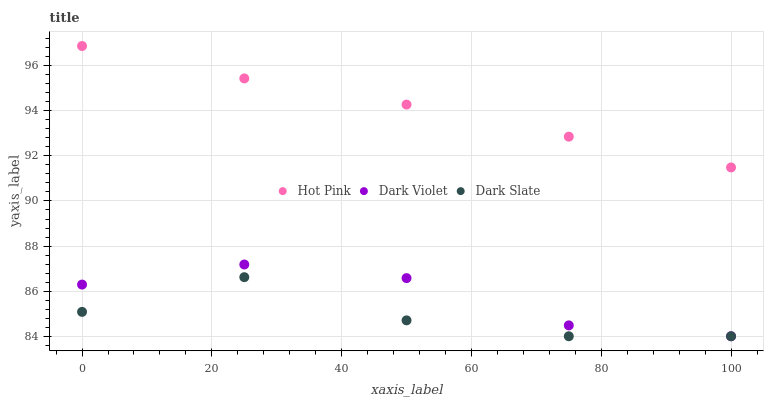Does Dark Slate have the minimum area under the curve?
Answer yes or no. Yes. Does Hot Pink have the maximum area under the curve?
Answer yes or no. Yes. Does Dark Violet have the minimum area under the curve?
Answer yes or no. No. Does Dark Violet have the maximum area under the curve?
Answer yes or no. No. Is Hot Pink the smoothest?
Answer yes or no. Yes. Is Dark Slate the roughest?
Answer yes or no. Yes. Is Dark Violet the smoothest?
Answer yes or no. No. Is Dark Violet the roughest?
Answer yes or no. No. Does Dark Slate have the lowest value?
Answer yes or no. Yes. Does Hot Pink have the lowest value?
Answer yes or no. No. Does Hot Pink have the highest value?
Answer yes or no. Yes. Does Dark Violet have the highest value?
Answer yes or no. No. Is Dark Slate less than Hot Pink?
Answer yes or no. Yes. Is Hot Pink greater than Dark Violet?
Answer yes or no. Yes. Does Dark Slate intersect Dark Violet?
Answer yes or no. Yes. Is Dark Slate less than Dark Violet?
Answer yes or no. No. Is Dark Slate greater than Dark Violet?
Answer yes or no. No. Does Dark Slate intersect Hot Pink?
Answer yes or no. No. 